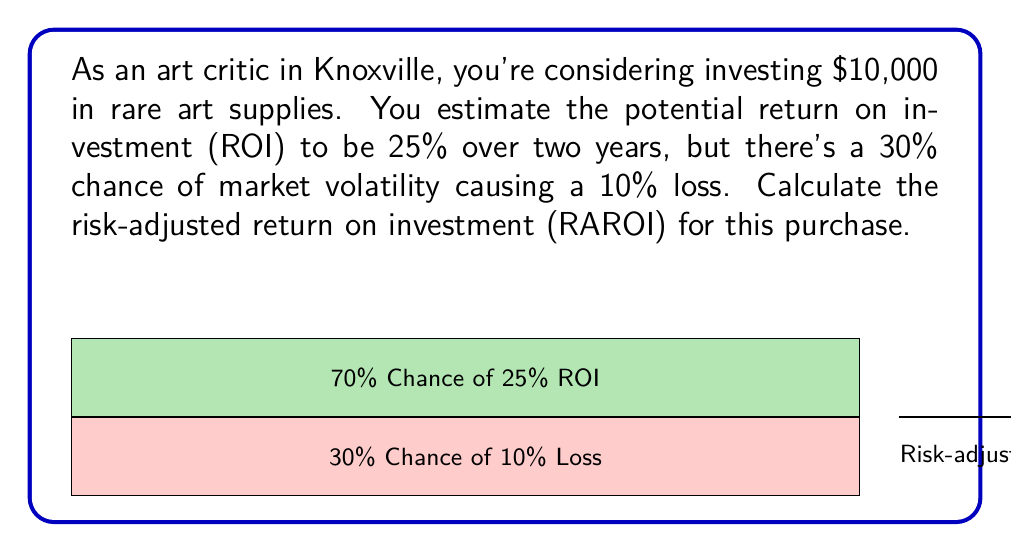Give your solution to this math problem. To calculate the risk-adjusted return on investment (RAROI), we need to follow these steps:

1. Calculate the expected return:
   $$E(R) = (0.70 \times 0.25) + (0.30 \times (-0.10)) = 0.175 - 0.03 = 0.145 \text{ or } 14.5\%$$

2. Calculate the standard deviation of returns:
   $$\sigma = \sqrt{0.70(0.25 - 0.145)^2 + 0.30(-0.10 - 0.145)^2} = 0.1483$$

3. Assume a risk-free rate (let's use 2% for this example):
   $$R_f = 0.02$$

4. Calculate the Sharpe ratio:
   $$\text{Sharpe Ratio} = \frac{E(R) - R_f}{\sigma} = \frac{0.145 - 0.02}{0.1483} = 0.8428$$

5. Calculate the RAROI:
   $$\text{RAROI} = R_f + \text{Sharpe Ratio} \times \sigma = 0.02 + 0.8428 \times 0.1483 = 0.145 \text{ or } 14.5\%$$

The RAROI is equal to the expected return in this case because we've accounted for the risk in our calculation.
Answer: 14.5% 